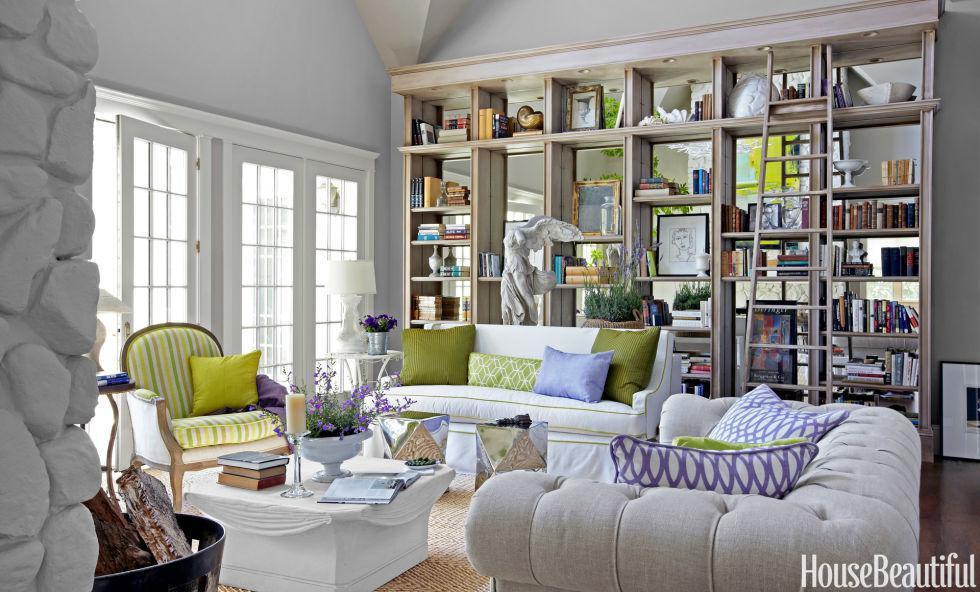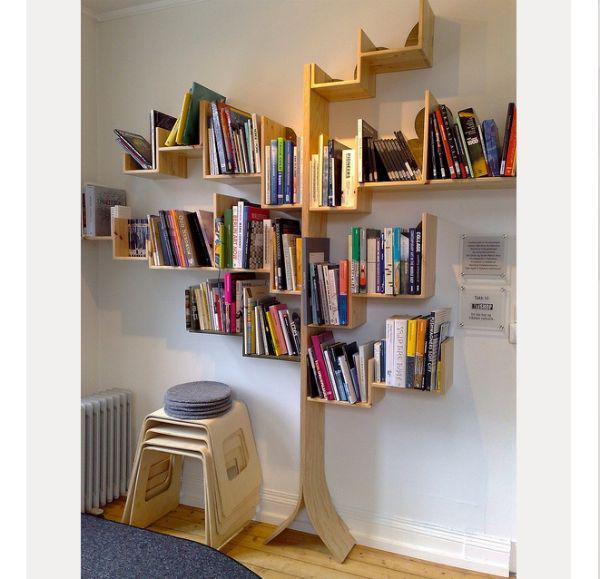The first image is the image on the left, the second image is the image on the right. Evaluate the accuracy of this statement regarding the images: "A window is visible in at least one of the images.". Is it true? Answer yes or no. Yes. The first image is the image on the left, the second image is the image on the right. Considering the images on both sides, is "An image shows a tree-inspired wooden bookshelf with platform shelves." valid? Answer yes or no. Yes. 